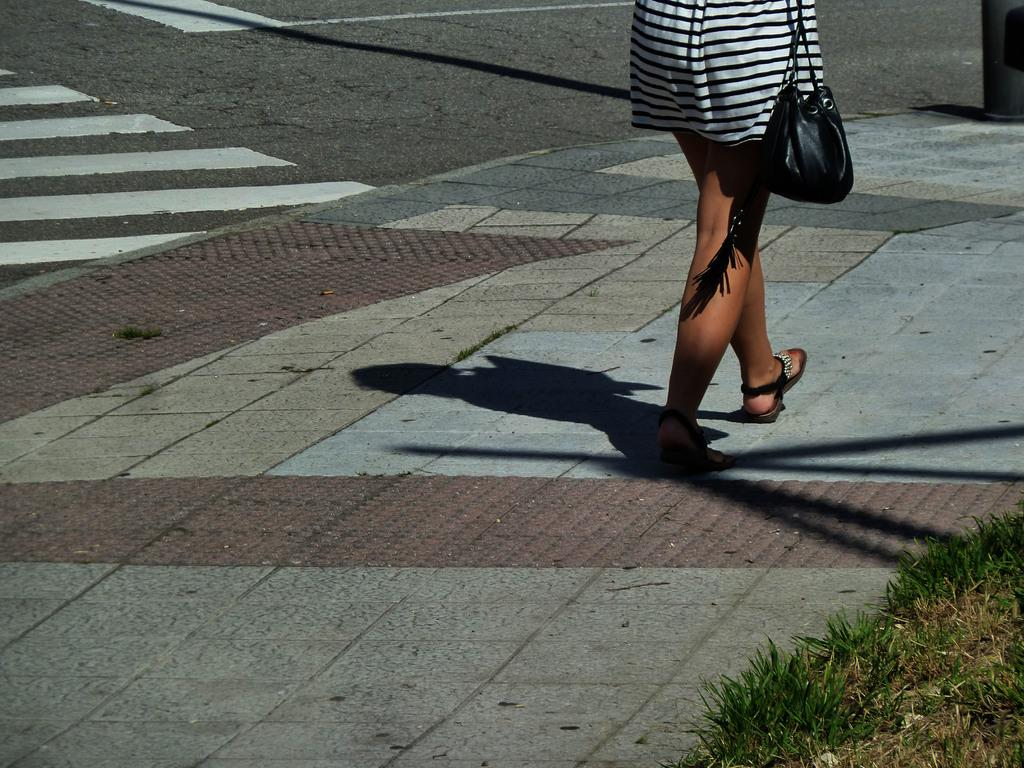Who is present in the image? There is a woman in the image. What is the woman doing in the image? The woman is walking on a pathway. What type of vegetation is visible beside the pathway? There is grass beside the pathway. What object can be seen on the right side of the image? There is a metal rod on the right side of the image. What item is visible in the image that the woman might be carrying? There is a bag visible in the image. Can you see a crack in the pathway in the image? There is no mention of a crack in the pathway in the provided facts, so we cannot determine if one is present in the image. 